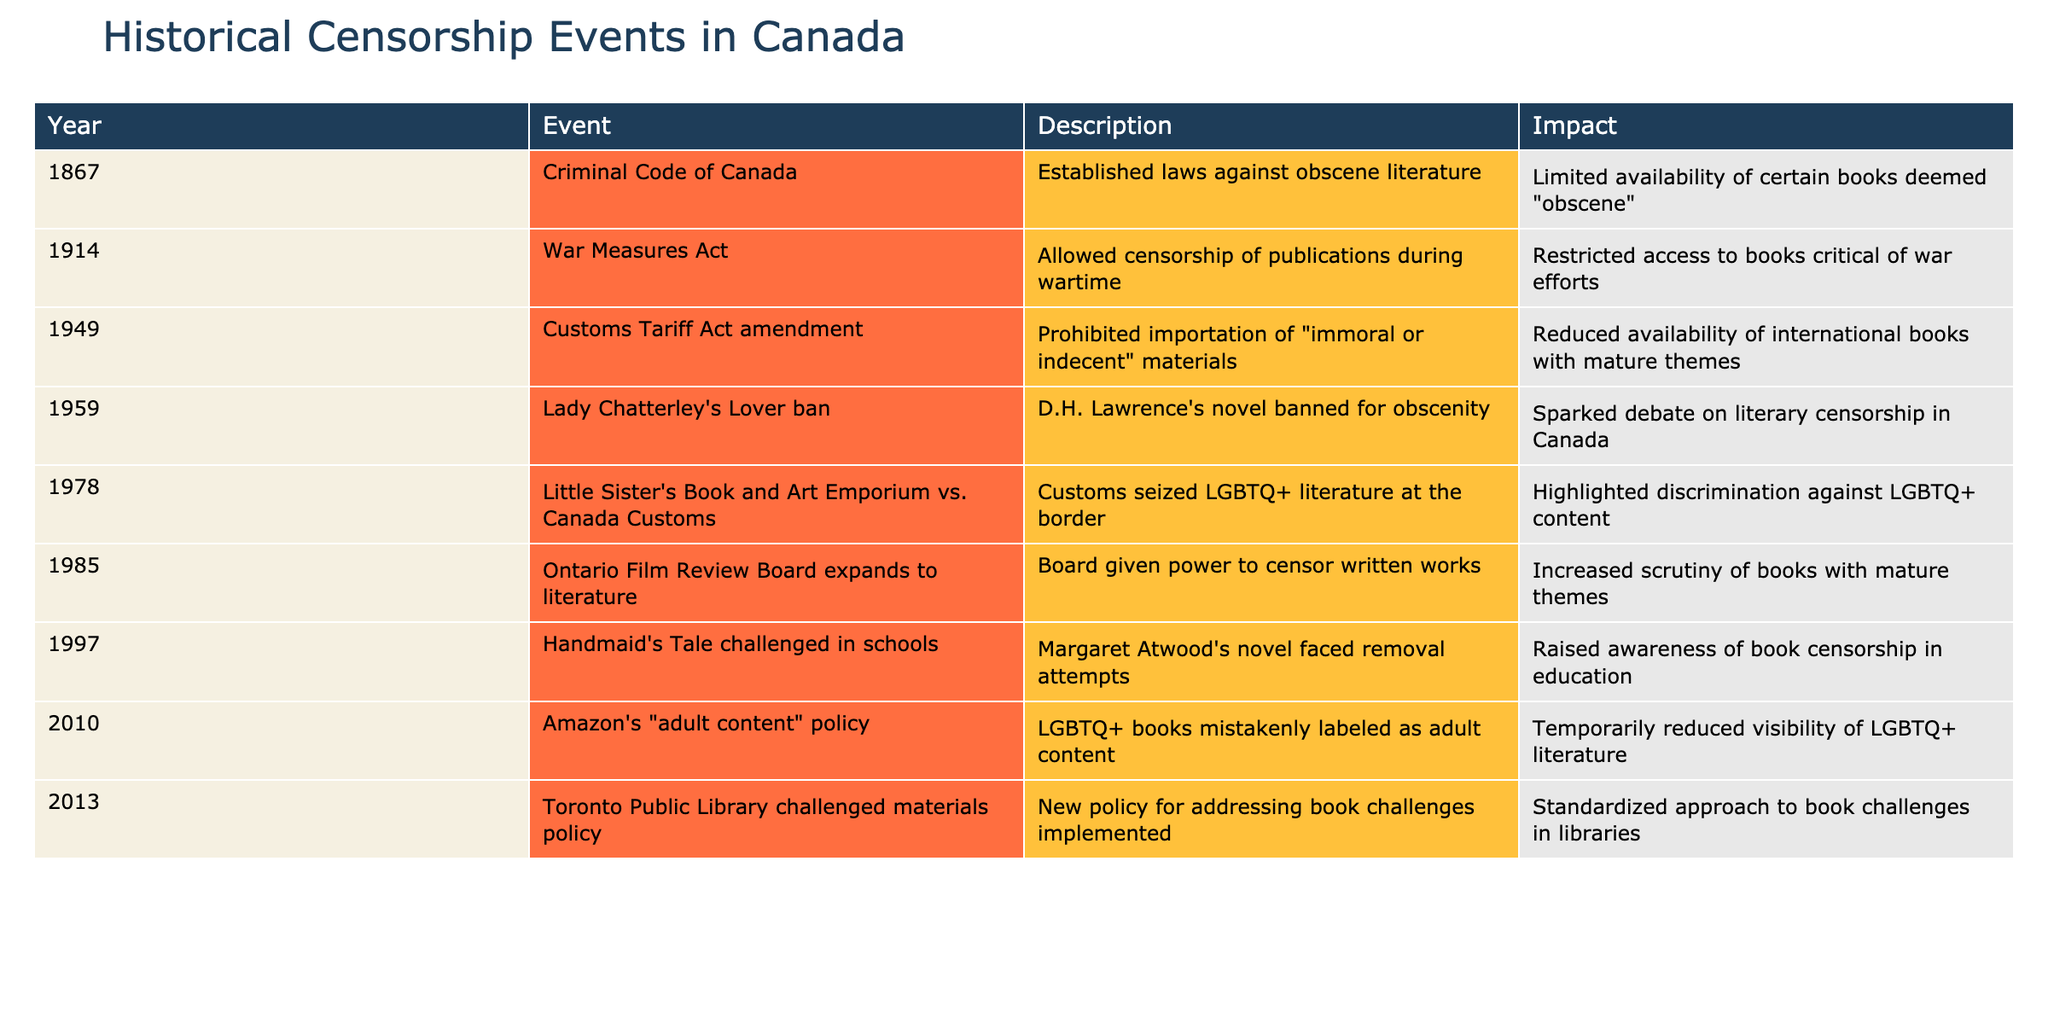What year was D.H. Lawrence's novel banned for obscenity? The table lists the event "Lady Chatterley's Lover ban" occurring in 1959, directly indicating the year it was banned.
Answer: 1959 Which event was associated with increased scrutiny of books with mature themes? The event listed as "Ontario Film Review Board expands to literature" in 1985 describes a significant increase in scrutiny of literary works.
Answer: Ontario Film Review Board expands to literature Was the Criminal Code of Canada established before or after 1949? The event "Criminal Code of Canada" is noted to have occurred in 1867. Since 1867 is before 1949, the answer verifies that it predates 1949.
Answer: Before How many events occurred after 2000? By counting the relevant events listed in the table, we see that there are two events dated after 2000: "Amazon's 'adult content' policy" in 2010 and "Toronto Public Library challenged materials policy" in 2013.
Answer: 2 Was there any event that specifically prohibited importation of certain materials? The "Customs Tariff Act amendment" in 1949 explicitly mentions the prohibition of importing "immoral or indecent" materials, confirming the specific prohibition.
Answer: Yes What is the impact of the event in 1914? The event "War Measures Act" in 1914 is described as allowing censorship of publications during wartime, leading to restricted access to books critical of war efforts. This summarizes the event's impact.
Answer: Restricted access to critical books List the events that involved discrimination against LGBTQ+ content. Reviewing the table, two events pertain to LGBTQ+ discrimination: "Little Sister's Book and Art Emporium vs. Canada Customs" in 1978 and "Amazon's 'adult content' policy" in 2010. This involves analyzing years and specific events that indicate LGBTQ+ focus.
Answer: 1978 and 2010 Which event marks a turning point in awareness of book censorship in education? The event "Handmaid's Tale challenged in schools" in 1997 indicates a significant challenge to a well-known novel, thus raising awareness of the censorship issue within educational contexts.
Answer: Handmaid's Tale challenged in schools What are the impacts of events related to LGBTQ+ literature? Evaluating multiple entries, we note that both the 1978 event regarding customs seizures and the 2010 event regarding Amazon's adult content policy significantly impacted LGBTQ+ literature visibility and availability.
Answer: Reduced visibility and access 